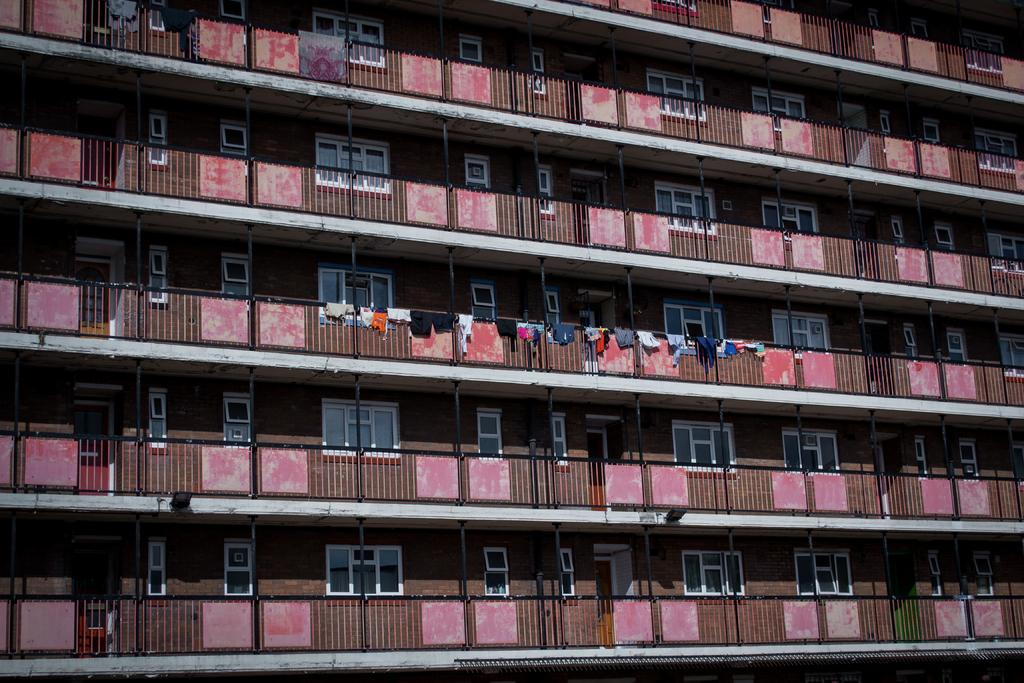What is the main subject of the picture? The main subject of the picture is a building. What specific features can be observed on the building? The building has windows. What else is visible in the picture besides the building? Clothes are visible in the picture. Can you tell me how many horses are in the picture? There are no horses present in the picture; it features a building with windows and visible clothes. 